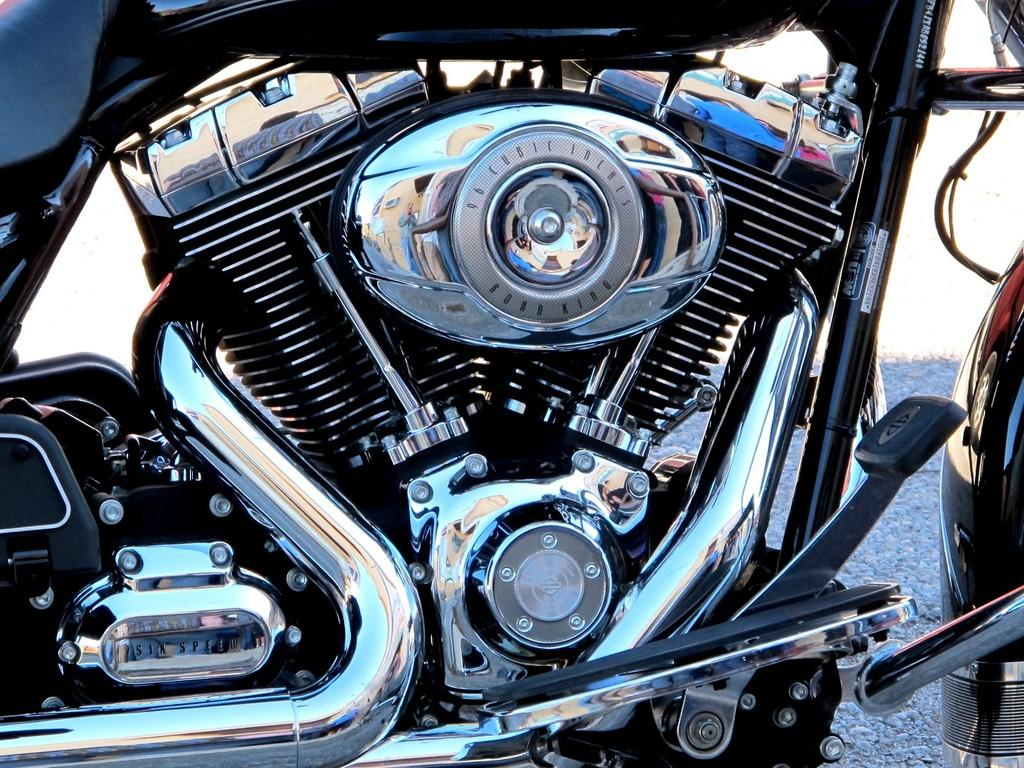What type of vehicle parts are present in the image? The image contains motorcycle parts. Can you name some specific motorcycle parts visible in the image? The motorcycle parts include an engine, a radiator, an exhaust pipe, a gear, rods, nuts, and other unspecified parts. Are there any additional elements visible in the image besides the motorcycle parts? Yes, there are wires visible in the image. What type of flower can be seen growing on the motorcycle parts in the image? There are no flowers present in the image; it contains motorcycle parts and wires. Can you describe the texture of the zipper on the motorcycle parts in the image? There are no zippers present on the motorcycle parts in the image. 